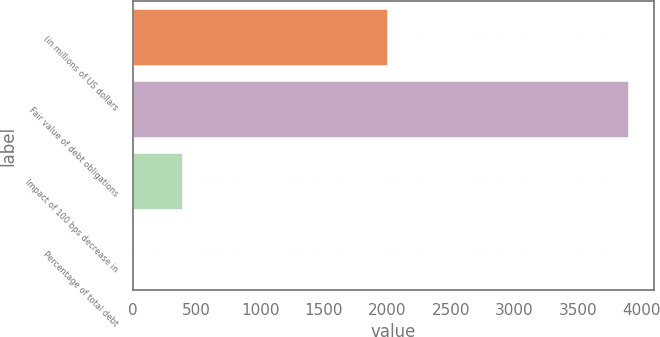Convert chart. <chart><loc_0><loc_0><loc_500><loc_500><bar_chart><fcel>(in millions of US dollars<fcel>Fair value of debt obligations<fcel>Impact of 100 bps decrease in<fcel>Percentage of total debt<nl><fcel>2009<fcel>3905<fcel>396.08<fcel>6.2<nl></chart> 